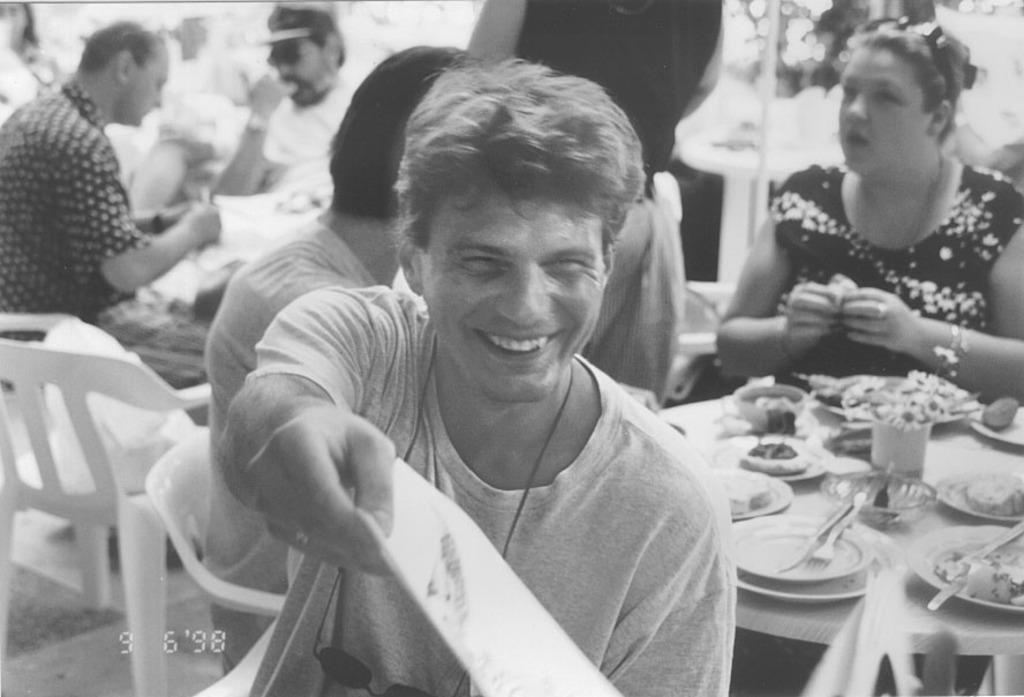What are the people in the image doing? The people in the image are sitting on chairs. What is present on the table in the image? There are plates, bowls, forks, and spoons on the table. What might the people be using the forks and spoons for? The forks and spoons are likely for eating, as they are on the table with plates and bowls. What type of sidewalk can be seen in the image? There is no sidewalk present in the image; it features people sitting on chairs and a table with plates, bowls, forks, and spoons. 